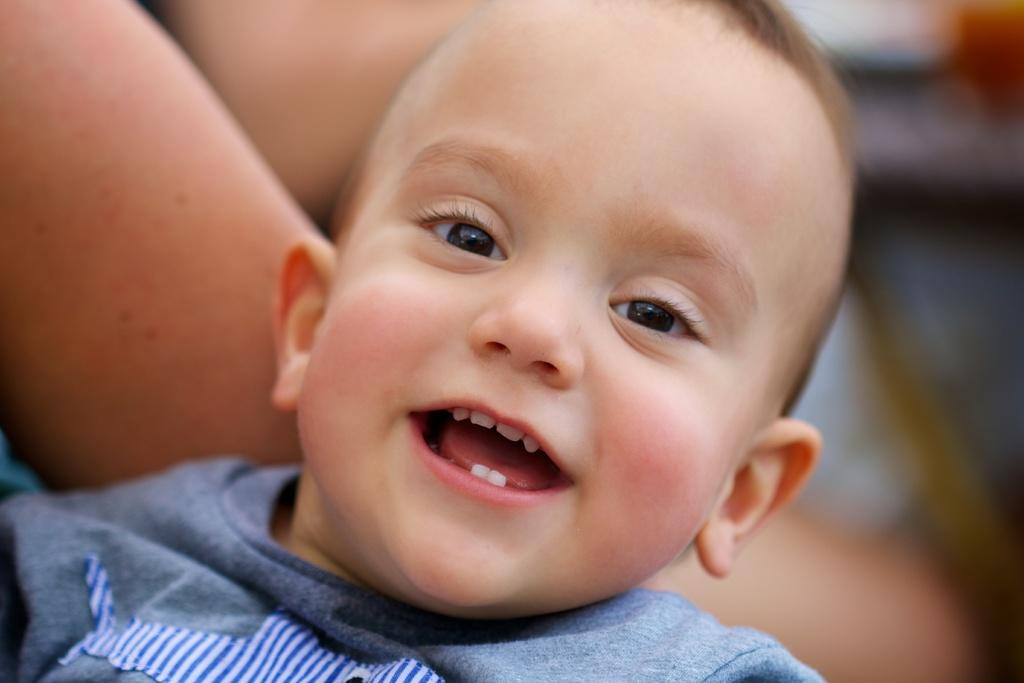Who or what can be seen in the image? There are people in the image. Can you describe the background on the right side of the image? The background on the right side of the image is blurred. What type of rifle is visible in the image? There is no rifle present in the image. What is the cause of the fog in the image? There is no fog present in the image; it is the blurred background on the right side. 